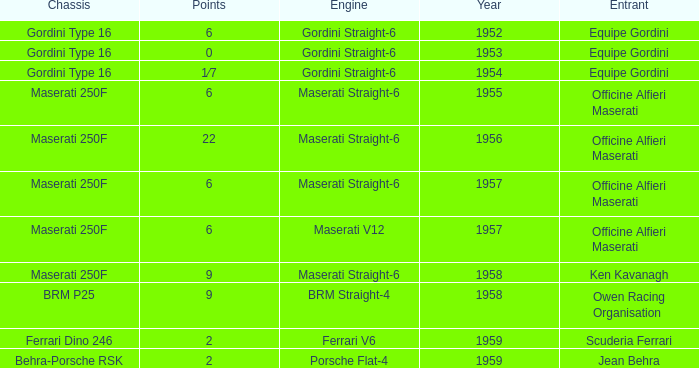What is the entrant of a chassis maserati 250f, also has 6 points and older than year 1957? Officine Alfieri Maserati. 